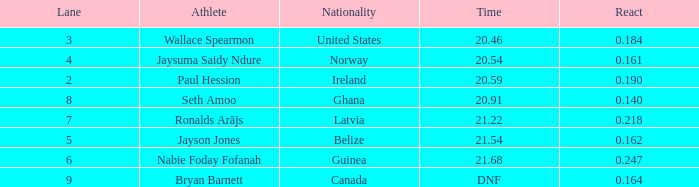What is the lowest lane when react is more than 0.164 and the nationality is guinea? 6.0. 